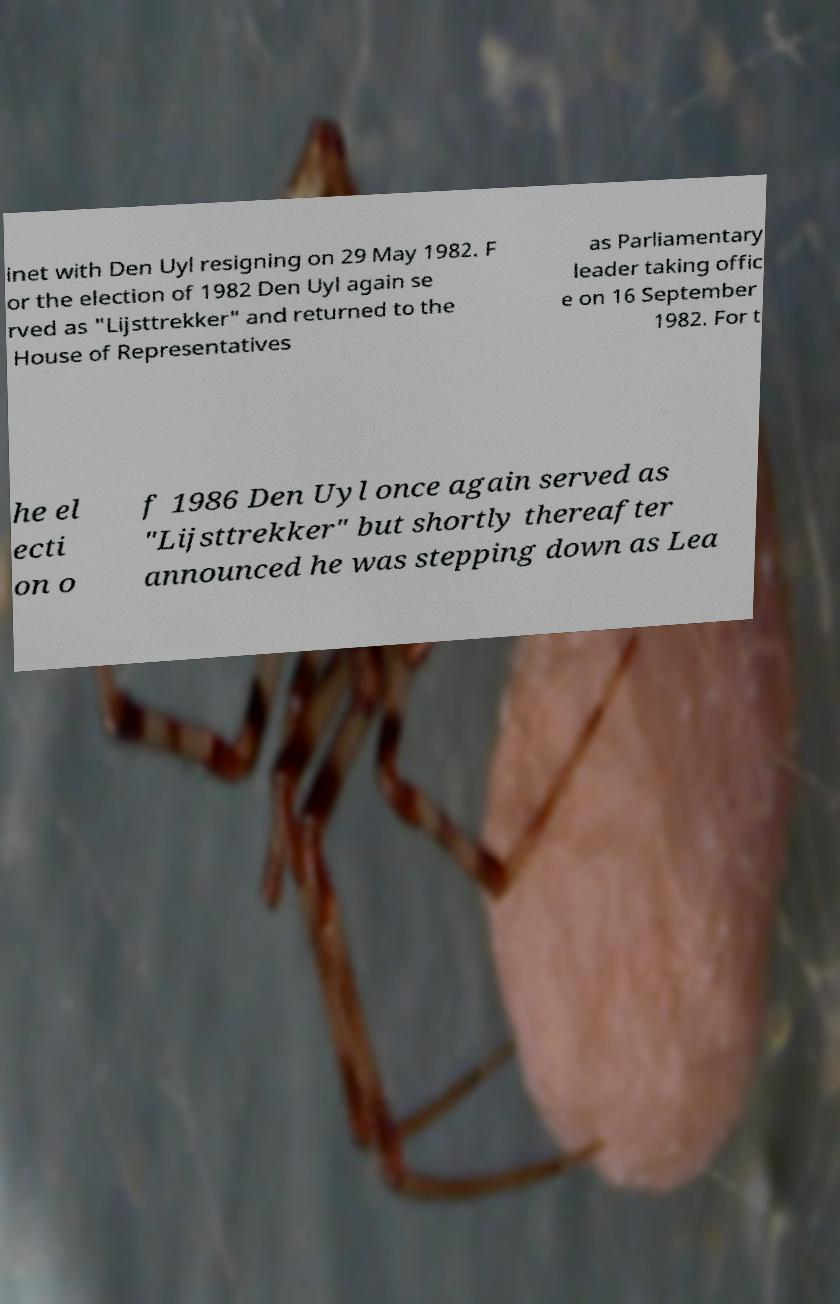Please identify and transcribe the text found in this image. inet with Den Uyl resigning on 29 May 1982. F or the election of 1982 Den Uyl again se rved as "Lijsttrekker" and returned to the House of Representatives as Parliamentary leader taking offic e on 16 September 1982. For t he el ecti on o f 1986 Den Uyl once again served as "Lijsttrekker" but shortly thereafter announced he was stepping down as Lea 